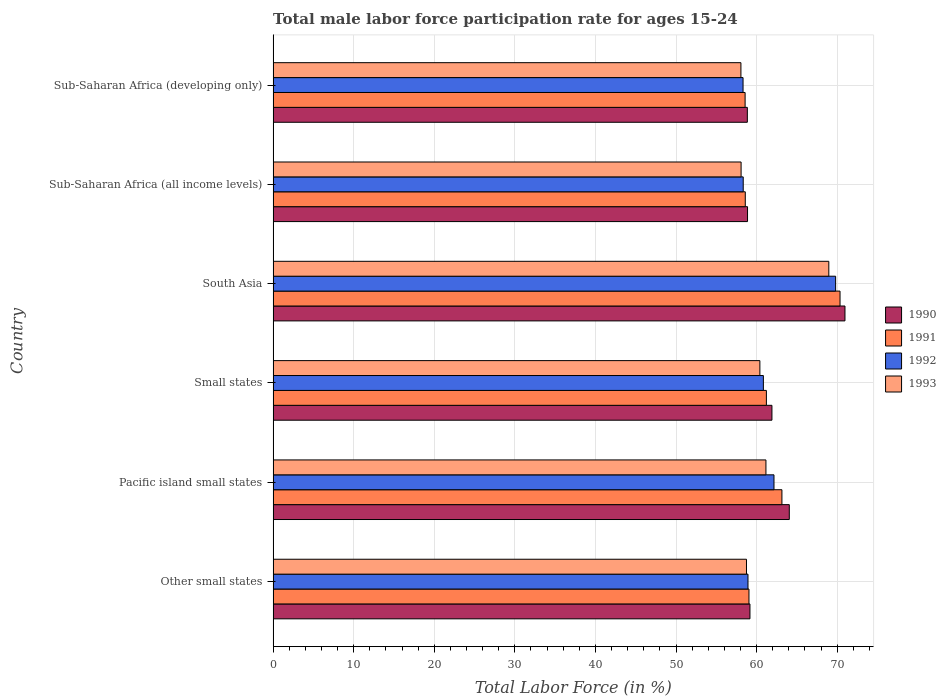How many different coloured bars are there?
Your answer should be very brief. 4. How many groups of bars are there?
Offer a terse response. 6. Are the number of bars on each tick of the Y-axis equal?
Your answer should be very brief. Yes. How many bars are there on the 4th tick from the bottom?
Your answer should be compact. 4. What is the label of the 5th group of bars from the top?
Your answer should be very brief. Pacific island small states. What is the male labor force participation rate in 1992 in South Asia?
Keep it short and to the point. 69.81. Across all countries, what is the maximum male labor force participation rate in 1992?
Keep it short and to the point. 69.81. Across all countries, what is the minimum male labor force participation rate in 1991?
Offer a terse response. 58.57. In which country was the male labor force participation rate in 1991 minimum?
Offer a very short reply. Sub-Saharan Africa (developing only). What is the total male labor force participation rate in 1991 in the graph?
Offer a terse response. 370.94. What is the difference between the male labor force participation rate in 1993 in Other small states and that in South Asia?
Give a very brief answer. -10.22. What is the difference between the male labor force participation rate in 1991 in Sub-Saharan Africa (all income levels) and the male labor force participation rate in 1992 in Other small states?
Provide a succinct answer. -0.34. What is the average male labor force participation rate in 1992 per country?
Your response must be concise. 61.4. What is the difference between the male labor force participation rate in 1993 and male labor force participation rate in 1992 in Pacific island small states?
Give a very brief answer. -1. In how many countries, is the male labor force participation rate in 1992 greater than 6 %?
Provide a succinct answer. 6. What is the ratio of the male labor force participation rate in 1993 in Other small states to that in South Asia?
Keep it short and to the point. 0.85. What is the difference between the highest and the second highest male labor force participation rate in 1991?
Make the answer very short. 7.21. What is the difference between the highest and the lowest male labor force participation rate in 1993?
Ensure brevity in your answer.  10.91. Is the sum of the male labor force participation rate in 1993 in South Asia and Sub-Saharan Africa (all income levels) greater than the maximum male labor force participation rate in 1992 across all countries?
Keep it short and to the point. Yes. Is it the case that in every country, the sum of the male labor force participation rate in 1992 and male labor force participation rate in 1993 is greater than the sum of male labor force participation rate in 1991 and male labor force participation rate in 1990?
Make the answer very short. No. What does the 2nd bar from the bottom in Sub-Saharan Africa (all income levels) represents?
Make the answer very short. 1991. Is it the case that in every country, the sum of the male labor force participation rate in 1990 and male labor force participation rate in 1993 is greater than the male labor force participation rate in 1992?
Keep it short and to the point. Yes. Are all the bars in the graph horizontal?
Ensure brevity in your answer.  Yes. How many countries are there in the graph?
Keep it short and to the point. 6. What is the difference between two consecutive major ticks on the X-axis?
Keep it short and to the point. 10. Are the values on the major ticks of X-axis written in scientific E-notation?
Give a very brief answer. No. Does the graph contain any zero values?
Provide a short and direct response. No. Where does the legend appear in the graph?
Provide a short and direct response. Center right. How are the legend labels stacked?
Offer a very short reply. Vertical. What is the title of the graph?
Provide a succinct answer. Total male labor force participation rate for ages 15-24. Does "2009" appear as one of the legend labels in the graph?
Your answer should be very brief. No. What is the label or title of the X-axis?
Make the answer very short. Total Labor Force (in %). What is the Total Labor Force (in %) of 1990 in Other small states?
Offer a very short reply. 59.18. What is the Total Labor Force (in %) in 1991 in Other small states?
Offer a very short reply. 59.05. What is the Total Labor Force (in %) of 1992 in Other small states?
Provide a succinct answer. 58.93. What is the Total Labor Force (in %) in 1993 in Other small states?
Offer a very short reply. 58.75. What is the Total Labor Force (in %) in 1990 in Pacific island small states?
Your answer should be compact. 64.06. What is the Total Labor Force (in %) in 1991 in Pacific island small states?
Make the answer very short. 63.15. What is the Total Labor Force (in %) of 1992 in Pacific island small states?
Your answer should be very brief. 62.16. What is the Total Labor Force (in %) of 1993 in Pacific island small states?
Your answer should be compact. 61.16. What is the Total Labor Force (in %) in 1990 in Small states?
Your response must be concise. 61.9. What is the Total Labor Force (in %) of 1991 in Small states?
Your answer should be very brief. 61.22. What is the Total Labor Force (in %) of 1992 in Small states?
Your answer should be compact. 60.84. What is the Total Labor Force (in %) in 1993 in Small states?
Provide a succinct answer. 60.41. What is the Total Labor Force (in %) in 1990 in South Asia?
Provide a succinct answer. 70.97. What is the Total Labor Force (in %) in 1991 in South Asia?
Offer a terse response. 70.36. What is the Total Labor Force (in %) of 1992 in South Asia?
Offer a very short reply. 69.81. What is the Total Labor Force (in %) in 1993 in South Asia?
Offer a terse response. 68.96. What is the Total Labor Force (in %) of 1990 in Sub-Saharan Africa (all income levels)?
Offer a terse response. 58.88. What is the Total Labor Force (in %) in 1991 in Sub-Saharan Africa (all income levels)?
Ensure brevity in your answer.  58.6. What is the Total Labor Force (in %) in 1992 in Sub-Saharan Africa (all income levels)?
Keep it short and to the point. 58.34. What is the Total Labor Force (in %) in 1993 in Sub-Saharan Africa (all income levels)?
Your answer should be compact. 58.08. What is the Total Labor Force (in %) in 1990 in Sub-Saharan Africa (developing only)?
Provide a short and direct response. 58.85. What is the Total Labor Force (in %) in 1991 in Sub-Saharan Africa (developing only)?
Provide a succinct answer. 58.57. What is the Total Labor Force (in %) of 1992 in Sub-Saharan Africa (developing only)?
Your response must be concise. 58.32. What is the Total Labor Force (in %) in 1993 in Sub-Saharan Africa (developing only)?
Ensure brevity in your answer.  58.06. Across all countries, what is the maximum Total Labor Force (in %) of 1990?
Keep it short and to the point. 70.97. Across all countries, what is the maximum Total Labor Force (in %) in 1991?
Keep it short and to the point. 70.36. Across all countries, what is the maximum Total Labor Force (in %) in 1992?
Your answer should be very brief. 69.81. Across all countries, what is the maximum Total Labor Force (in %) in 1993?
Offer a very short reply. 68.96. Across all countries, what is the minimum Total Labor Force (in %) in 1990?
Provide a succinct answer. 58.85. Across all countries, what is the minimum Total Labor Force (in %) in 1991?
Give a very brief answer. 58.57. Across all countries, what is the minimum Total Labor Force (in %) in 1992?
Your response must be concise. 58.32. Across all countries, what is the minimum Total Labor Force (in %) of 1993?
Offer a terse response. 58.06. What is the total Total Labor Force (in %) of 1990 in the graph?
Your answer should be very brief. 373.84. What is the total Total Labor Force (in %) of 1991 in the graph?
Ensure brevity in your answer.  370.94. What is the total Total Labor Force (in %) of 1992 in the graph?
Provide a short and direct response. 368.4. What is the total Total Labor Force (in %) in 1993 in the graph?
Offer a terse response. 365.41. What is the difference between the Total Labor Force (in %) of 1990 in Other small states and that in Pacific island small states?
Your answer should be compact. -4.88. What is the difference between the Total Labor Force (in %) of 1991 in Other small states and that in Pacific island small states?
Keep it short and to the point. -4.09. What is the difference between the Total Labor Force (in %) of 1992 in Other small states and that in Pacific island small states?
Offer a very short reply. -3.23. What is the difference between the Total Labor Force (in %) of 1993 in Other small states and that in Pacific island small states?
Your answer should be very brief. -2.42. What is the difference between the Total Labor Force (in %) of 1990 in Other small states and that in Small states?
Offer a very short reply. -2.73. What is the difference between the Total Labor Force (in %) in 1991 in Other small states and that in Small states?
Your answer should be very brief. -2.16. What is the difference between the Total Labor Force (in %) in 1992 in Other small states and that in Small states?
Provide a succinct answer. -1.91. What is the difference between the Total Labor Force (in %) of 1993 in Other small states and that in Small states?
Your answer should be compact. -1.66. What is the difference between the Total Labor Force (in %) in 1990 in Other small states and that in South Asia?
Make the answer very short. -11.79. What is the difference between the Total Labor Force (in %) in 1991 in Other small states and that in South Asia?
Your answer should be compact. -11.3. What is the difference between the Total Labor Force (in %) in 1992 in Other small states and that in South Asia?
Offer a very short reply. -10.88. What is the difference between the Total Labor Force (in %) of 1993 in Other small states and that in South Asia?
Offer a very short reply. -10.22. What is the difference between the Total Labor Force (in %) of 1990 in Other small states and that in Sub-Saharan Africa (all income levels)?
Offer a very short reply. 0.3. What is the difference between the Total Labor Force (in %) in 1991 in Other small states and that in Sub-Saharan Africa (all income levels)?
Provide a succinct answer. 0.46. What is the difference between the Total Labor Force (in %) of 1992 in Other small states and that in Sub-Saharan Africa (all income levels)?
Provide a short and direct response. 0.59. What is the difference between the Total Labor Force (in %) in 1993 in Other small states and that in Sub-Saharan Africa (all income levels)?
Give a very brief answer. 0.67. What is the difference between the Total Labor Force (in %) in 1990 in Other small states and that in Sub-Saharan Africa (developing only)?
Your answer should be compact. 0.32. What is the difference between the Total Labor Force (in %) in 1991 in Other small states and that in Sub-Saharan Africa (developing only)?
Your answer should be compact. 0.48. What is the difference between the Total Labor Force (in %) in 1992 in Other small states and that in Sub-Saharan Africa (developing only)?
Provide a succinct answer. 0.61. What is the difference between the Total Labor Force (in %) in 1993 in Other small states and that in Sub-Saharan Africa (developing only)?
Keep it short and to the point. 0.69. What is the difference between the Total Labor Force (in %) of 1990 in Pacific island small states and that in Small states?
Keep it short and to the point. 2.15. What is the difference between the Total Labor Force (in %) of 1991 in Pacific island small states and that in Small states?
Ensure brevity in your answer.  1.93. What is the difference between the Total Labor Force (in %) in 1992 in Pacific island small states and that in Small states?
Provide a succinct answer. 1.32. What is the difference between the Total Labor Force (in %) of 1993 in Pacific island small states and that in Small states?
Your answer should be very brief. 0.75. What is the difference between the Total Labor Force (in %) of 1990 in Pacific island small states and that in South Asia?
Your response must be concise. -6.91. What is the difference between the Total Labor Force (in %) in 1991 in Pacific island small states and that in South Asia?
Your answer should be compact. -7.21. What is the difference between the Total Labor Force (in %) of 1992 in Pacific island small states and that in South Asia?
Your response must be concise. -7.65. What is the difference between the Total Labor Force (in %) in 1993 in Pacific island small states and that in South Asia?
Your answer should be compact. -7.8. What is the difference between the Total Labor Force (in %) of 1990 in Pacific island small states and that in Sub-Saharan Africa (all income levels)?
Provide a short and direct response. 5.18. What is the difference between the Total Labor Force (in %) of 1991 in Pacific island small states and that in Sub-Saharan Africa (all income levels)?
Offer a terse response. 4.55. What is the difference between the Total Labor Force (in %) of 1992 in Pacific island small states and that in Sub-Saharan Africa (all income levels)?
Offer a very short reply. 3.82. What is the difference between the Total Labor Force (in %) of 1993 in Pacific island small states and that in Sub-Saharan Africa (all income levels)?
Your answer should be compact. 3.08. What is the difference between the Total Labor Force (in %) of 1990 in Pacific island small states and that in Sub-Saharan Africa (developing only)?
Your answer should be compact. 5.21. What is the difference between the Total Labor Force (in %) in 1991 in Pacific island small states and that in Sub-Saharan Africa (developing only)?
Your answer should be very brief. 4.57. What is the difference between the Total Labor Force (in %) of 1992 in Pacific island small states and that in Sub-Saharan Africa (developing only)?
Provide a succinct answer. 3.84. What is the difference between the Total Labor Force (in %) of 1993 in Pacific island small states and that in Sub-Saharan Africa (developing only)?
Ensure brevity in your answer.  3.1. What is the difference between the Total Labor Force (in %) of 1990 in Small states and that in South Asia?
Offer a terse response. -9.06. What is the difference between the Total Labor Force (in %) of 1991 in Small states and that in South Asia?
Give a very brief answer. -9.14. What is the difference between the Total Labor Force (in %) in 1992 in Small states and that in South Asia?
Ensure brevity in your answer.  -8.97. What is the difference between the Total Labor Force (in %) in 1993 in Small states and that in South Asia?
Make the answer very short. -8.55. What is the difference between the Total Labor Force (in %) of 1990 in Small states and that in Sub-Saharan Africa (all income levels)?
Your response must be concise. 3.03. What is the difference between the Total Labor Force (in %) of 1991 in Small states and that in Sub-Saharan Africa (all income levels)?
Ensure brevity in your answer.  2.62. What is the difference between the Total Labor Force (in %) of 1992 in Small states and that in Sub-Saharan Africa (all income levels)?
Make the answer very short. 2.5. What is the difference between the Total Labor Force (in %) of 1993 in Small states and that in Sub-Saharan Africa (all income levels)?
Provide a succinct answer. 2.33. What is the difference between the Total Labor Force (in %) of 1990 in Small states and that in Sub-Saharan Africa (developing only)?
Provide a succinct answer. 3.05. What is the difference between the Total Labor Force (in %) in 1991 in Small states and that in Sub-Saharan Africa (developing only)?
Your answer should be very brief. 2.64. What is the difference between the Total Labor Force (in %) of 1992 in Small states and that in Sub-Saharan Africa (developing only)?
Provide a short and direct response. 2.52. What is the difference between the Total Labor Force (in %) in 1993 in Small states and that in Sub-Saharan Africa (developing only)?
Keep it short and to the point. 2.35. What is the difference between the Total Labor Force (in %) of 1990 in South Asia and that in Sub-Saharan Africa (all income levels)?
Your answer should be very brief. 12.09. What is the difference between the Total Labor Force (in %) of 1991 in South Asia and that in Sub-Saharan Africa (all income levels)?
Your response must be concise. 11.76. What is the difference between the Total Labor Force (in %) in 1992 in South Asia and that in Sub-Saharan Africa (all income levels)?
Provide a short and direct response. 11.47. What is the difference between the Total Labor Force (in %) in 1993 in South Asia and that in Sub-Saharan Africa (all income levels)?
Offer a terse response. 10.89. What is the difference between the Total Labor Force (in %) of 1990 in South Asia and that in Sub-Saharan Africa (developing only)?
Make the answer very short. 12.11. What is the difference between the Total Labor Force (in %) of 1991 in South Asia and that in Sub-Saharan Africa (developing only)?
Offer a terse response. 11.78. What is the difference between the Total Labor Force (in %) of 1992 in South Asia and that in Sub-Saharan Africa (developing only)?
Give a very brief answer. 11.49. What is the difference between the Total Labor Force (in %) of 1993 in South Asia and that in Sub-Saharan Africa (developing only)?
Your response must be concise. 10.91. What is the difference between the Total Labor Force (in %) in 1990 in Sub-Saharan Africa (all income levels) and that in Sub-Saharan Africa (developing only)?
Your response must be concise. 0.02. What is the difference between the Total Labor Force (in %) in 1991 in Sub-Saharan Africa (all income levels) and that in Sub-Saharan Africa (developing only)?
Give a very brief answer. 0.02. What is the difference between the Total Labor Force (in %) in 1992 in Sub-Saharan Africa (all income levels) and that in Sub-Saharan Africa (developing only)?
Your answer should be very brief. 0.02. What is the difference between the Total Labor Force (in %) in 1993 in Sub-Saharan Africa (all income levels) and that in Sub-Saharan Africa (developing only)?
Offer a terse response. 0.02. What is the difference between the Total Labor Force (in %) in 1990 in Other small states and the Total Labor Force (in %) in 1991 in Pacific island small states?
Offer a terse response. -3.97. What is the difference between the Total Labor Force (in %) of 1990 in Other small states and the Total Labor Force (in %) of 1992 in Pacific island small states?
Your response must be concise. -2.98. What is the difference between the Total Labor Force (in %) of 1990 in Other small states and the Total Labor Force (in %) of 1993 in Pacific island small states?
Offer a very short reply. -1.98. What is the difference between the Total Labor Force (in %) of 1991 in Other small states and the Total Labor Force (in %) of 1992 in Pacific island small states?
Your response must be concise. -3.1. What is the difference between the Total Labor Force (in %) in 1991 in Other small states and the Total Labor Force (in %) in 1993 in Pacific island small states?
Your answer should be very brief. -2.11. What is the difference between the Total Labor Force (in %) of 1992 in Other small states and the Total Labor Force (in %) of 1993 in Pacific island small states?
Provide a succinct answer. -2.23. What is the difference between the Total Labor Force (in %) in 1990 in Other small states and the Total Labor Force (in %) in 1991 in Small states?
Give a very brief answer. -2.04. What is the difference between the Total Labor Force (in %) in 1990 in Other small states and the Total Labor Force (in %) in 1992 in Small states?
Your answer should be compact. -1.67. What is the difference between the Total Labor Force (in %) of 1990 in Other small states and the Total Labor Force (in %) of 1993 in Small states?
Give a very brief answer. -1.23. What is the difference between the Total Labor Force (in %) in 1991 in Other small states and the Total Labor Force (in %) in 1992 in Small states?
Your answer should be compact. -1.79. What is the difference between the Total Labor Force (in %) of 1991 in Other small states and the Total Labor Force (in %) of 1993 in Small states?
Your answer should be very brief. -1.35. What is the difference between the Total Labor Force (in %) in 1992 in Other small states and the Total Labor Force (in %) in 1993 in Small states?
Make the answer very short. -1.48. What is the difference between the Total Labor Force (in %) in 1990 in Other small states and the Total Labor Force (in %) in 1991 in South Asia?
Keep it short and to the point. -11.18. What is the difference between the Total Labor Force (in %) in 1990 in Other small states and the Total Labor Force (in %) in 1992 in South Asia?
Your answer should be compact. -10.63. What is the difference between the Total Labor Force (in %) of 1990 in Other small states and the Total Labor Force (in %) of 1993 in South Asia?
Your answer should be compact. -9.79. What is the difference between the Total Labor Force (in %) in 1991 in Other small states and the Total Labor Force (in %) in 1992 in South Asia?
Keep it short and to the point. -10.75. What is the difference between the Total Labor Force (in %) in 1991 in Other small states and the Total Labor Force (in %) in 1993 in South Asia?
Provide a succinct answer. -9.91. What is the difference between the Total Labor Force (in %) in 1992 in Other small states and the Total Labor Force (in %) in 1993 in South Asia?
Your response must be concise. -10.03. What is the difference between the Total Labor Force (in %) in 1990 in Other small states and the Total Labor Force (in %) in 1991 in Sub-Saharan Africa (all income levels)?
Provide a succinct answer. 0.58. What is the difference between the Total Labor Force (in %) of 1990 in Other small states and the Total Labor Force (in %) of 1992 in Sub-Saharan Africa (all income levels)?
Ensure brevity in your answer.  0.84. What is the difference between the Total Labor Force (in %) in 1990 in Other small states and the Total Labor Force (in %) in 1993 in Sub-Saharan Africa (all income levels)?
Your answer should be very brief. 1.1. What is the difference between the Total Labor Force (in %) in 1991 in Other small states and the Total Labor Force (in %) in 1992 in Sub-Saharan Africa (all income levels)?
Your answer should be very brief. 0.71. What is the difference between the Total Labor Force (in %) of 1991 in Other small states and the Total Labor Force (in %) of 1993 in Sub-Saharan Africa (all income levels)?
Your answer should be compact. 0.98. What is the difference between the Total Labor Force (in %) of 1992 in Other small states and the Total Labor Force (in %) of 1993 in Sub-Saharan Africa (all income levels)?
Make the answer very short. 0.86. What is the difference between the Total Labor Force (in %) of 1990 in Other small states and the Total Labor Force (in %) of 1991 in Sub-Saharan Africa (developing only)?
Provide a short and direct response. 0.6. What is the difference between the Total Labor Force (in %) of 1990 in Other small states and the Total Labor Force (in %) of 1992 in Sub-Saharan Africa (developing only)?
Your answer should be very brief. 0.86. What is the difference between the Total Labor Force (in %) in 1990 in Other small states and the Total Labor Force (in %) in 1993 in Sub-Saharan Africa (developing only)?
Provide a succinct answer. 1.12. What is the difference between the Total Labor Force (in %) in 1991 in Other small states and the Total Labor Force (in %) in 1992 in Sub-Saharan Africa (developing only)?
Provide a succinct answer. 0.73. What is the difference between the Total Labor Force (in %) in 1992 in Other small states and the Total Labor Force (in %) in 1993 in Sub-Saharan Africa (developing only)?
Your answer should be very brief. 0.88. What is the difference between the Total Labor Force (in %) in 1990 in Pacific island small states and the Total Labor Force (in %) in 1991 in Small states?
Make the answer very short. 2.84. What is the difference between the Total Labor Force (in %) of 1990 in Pacific island small states and the Total Labor Force (in %) of 1992 in Small states?
Provide a succinct answer. 3.22. What is the difference between the Total Labor Force (in %) of 1990 in Pacific island small states and the Total Labor Force (in %) of 1993 in Small states?
Offer a very short reply. 3.65. What is the difference between the Total Labor Force (in %) of 1991 in Pacific island small states and the Total Labor Force (in %) of 1992 in Small states?
Offer a very short reply. 2.3. What is the difference between the Total Labor Force (in %) in 1991 in Pacific island small states and the Total Labor Force (in %) in 1993 in Small states?
Give a very brief answer. 2.74. What is the difference between the Total Labor Force (in %) in 1992 in Pacific island small states and the Total Labor Force (in %) in 1993 in Small states?
Your response must be concise. 1.75. What is the difference between the Total Labor Force (in %) in 1990 in Pacific island small states and the Total Labor Force (in %) in 1991 in South Asia?
Your response must be concise. -6.3. What is the difference between the Total Labor Force (in %) of 1990 in Pacific island small states and the Total Labor Force (in %) of 1992 in South Asia?
Make the answer very short. -5.75. What is the difference between the Total Labor Force (in %) of 1990 in Pacific island small states and the Total Labor Force (in %) of 1993 in South Asia?
Provide a succinct answer. -4.9. What is the difference between the Total Labor Force (in %) in 1991 in Pacific island small states and the Total Labor Force (in %) in 1992 in South Asia?
Offer a very short reply. -6.66. What is the difference between the Total Labor Force (in %) of 1991 in Pacific island small states and the Total Labor Force (in %) of 1993 in South Asia?
Ensure brevity in your answer.  -5.82. What is the difference between the Total Labor Force (in %) in 1992 in Pacific island small states and the Total Labor Force (in %) in 1993 in South Asia?
Keep it short and to the point. -6.8. What is the difference between the Total Labor Force (in %) in 1990 in Pacific island small states and the Total Labor Force (in %) in 1991 in Sub-Saharan Africa (all income levels)?
Keep it short and to the point. 5.46. What is the difference between the Total Labor Force (in %) in 1990 in Pacific island small states and the Total Labor Force (in %) in 1992 in Sub-Saharan Africa (all income levels)?
Give a very brief answer. 5.72. What is the difference between the Total Labor Force (in %) of 1990 in Pacific island small states and the Total Labor Force (in %) of 1993 in Sub-Saharan Africa (all income levels)?
Provide a succinct answer. 5.98. What is the difference between the Total Labor Force (in %) in 1991 in Pacific island small states and the Total Labor Force (in %) in 1992 in Sub-Saharan Africa (all income levels)?
Your answer should be compact. 4.8. What is the difference between the Total Labor Force (in %) in 1991 in Pacific island small states and the Total Labor Force (in %) in 1993 in Sub-Saharan Africa (all income levels)?
Give a very brief answer. 5.07. What is the difference between the Total Labor Force (in %) of 1992 in Pacific island small states and the Total Labor Force (in %) of 1993 in Sub-Saharan Africa (all income levels)?
Your answer should be very brief. 4.08. What is the difference between the Total Labor Force (in %) in 1990 in Pacific island small states and the Total Labor Force (in %) in 1991 in Sub-Saharan Africa (developing only)?
Your response must be concise. 5.48. What is the difference between the Total Labor Force (in %) in 1990 in Pacific island small states and the Total Labor Force (in %) in 1992 in Sub-Saharan Africa (developing only)?
Your answer should be compact. 5.74. What is the difference between the Total Labor Force (in %) of 1990 in Pacific island small states and the Total Labor Force (in %) of 1993 in Sub-Saharan Africa (developing only)?
Offer a terse response. 6. What is the difference between the Total Labor Force (in %) in 1991 in Pacific island small states and the Total Labor Force (in %) in 1992 in Sub-Saharan Africa (developing only)?
Make the answer very short. 4.83. What is the difference between the Total Labor Force (in %) of 1991 in Pacific island small states and the Total Labor Force (in %) of 1993 in Sub-Saharan Africa (developing only)?
Your answer should be very brief. 5.09. What is the difference between the Total Labor Force (in %) of 1992 in Pacific island small states and the Total Labor Force (in %) of 1993 in Sub-Saharan Africa (developing only)?
Your answer should be compact. 4.1. What is the difference between the Total Labor Force (in %) in 1990 in Small states and the Total Labor Force (in %) in 1991 in South Asia?
Provide a short and direct response. -8.45. What is the difference between the Total Labor Force (in %) of 1990 in Small states and the Total Labor Force (in %) of 1992 in South Asia?
Offer a terse response. -7.9. What is the difference between the Total Labor Force (in %) in 1990 in Small states and the Total Labor Force (in %) in 1993 in South Asia?
Keep it short and to the point. -7.06. What is the difference between the Total Labor Force (in %) of 1991 in Small states and the Total Labor Force (in %) of 1992 in South Asia?
Your answer should be compact. -8.59. What is the difference between the Total Labor Force (in %) of 1991 in Small states and the Total Labor Force (in %) of 1993 in South Asia?
Provide a succinct answer. -7.75. What is the difference between the Total Labor Force (in %) of 1992 in Small states and the Total Labor Force (in %) of 1993 in South Asia?
Offer a terse response. -8.12. What is the difference between the Total Labor Force (in %) of 1990 in Small states and the Total Labor Force (in %) of 1991 in Sub-Saharan Africa (all income levels)?
Your response must be concise. 3.31. What is the difference between the Total Labor Force (in %) in 1990 in Small states and the Total Labor Force (in %) in 1992 in Sub-Saharan Africa (all income levels)?
Make the answer very short. 3.56. What is the difference between the Total Labor Force (in %) of 1990 in Small states and the Total Labor Force (in %) of 1993 in Sub-Saharan Africa (all income levels)?
Your answer should be compact. 3.83. What is the difference between the Total Labor Force (in %) in 1991 in Small states and the Total Labor Force (in %) in 1992 in Sub-Saharan Africa (all income levels)?
Offer a terse response. 2.88. What is the difference between the Total Labor Force (in %) of 1991 in Small states and the Total Labor Force (in %) of 1993 in Sub-Saharan Africa (all income levels)?
Make the answer very short. 3.14. What is the difference between the Total Labor Force (in %) of 1992 in Small states and the Total Labor Force (in %) of 1993 in Sub-Saharan Africa (all income levels)?
Provide a short and direct response. 2.77. What is the difference between the Total Labor Force (in %) of 1990 in Small states and the Total Labor Force (in %) of 1991 in Sub-Saharan Africa (developing only)?
Make the answer very short. 3.33. What is the difference between the Total Labor Force (in %) in 1990 in Small states and the Total Labor Force (in %) in 1992 in Sub-Saharan Africa (developing only)?
Keep it short and to the point. 3.58. What is the difference between the Total Labor Force (in %) in 1990 in Small states and the Total Labor Force (in %) in 1993 in Sub-Saharan Africa (developing only)?
Provide a short and direct response. 3.85. What is the difference between the Total Labor Force (in %) in 1991 in Small states and the Total Labor Force (in %) in 1992 in Sub-Saharan Africa (developing only)?
Your response must be concise. 2.9. What is the difference between the Total Labor Force (in %) of 1991 in Small states and the Total Labor Force (in %) of 1993 in Sub-Saharan Africa (developing only)?
Keep it short and to the point. 3.16. What is the difference between the Total Labor Force (in %) in 1992 in Small states and the Total Labor Force (in %) in 1993 in Sub-Saharan Africa (developing only)?
Ensure brevity in your answer.  2.79. What is the difference between the Total Labor Force (in %) in 1990 in South Asia and the Total Labor Force (in %) in 1991 in Sub-Saharan Africa (all income levels)?
Your response must be concise. 12.37. What is the difference between the Total Labor Force (in %) in 1990 in South Asia and the Total Labor Force (in %) in 1992 in Sub-Saharan Africa (all income levels)?
Your answer should be compact. 12.63. What is the difference between the Total Labor Force (in %) of 1990 in South Asia and the Total Labor Force (in %) of 1993 in Sub-Saharan Africa (all income levels)?
Make the answer very short. 12.89. What is the difference between the Total Labor Force (in %) in 1991 in South Asia and the Total Labor Force (in %) in 1992 in Sub-Saharan Africa (all income levels)?
Your answer should be compact. 12.02. What is the difference between the Total Labor Force (in %) in 1991 in South Asia and the Total Labor Force (in %) in 1993 in Sub-Saharan Africa (all income levels)?
Your response must be concise. 12.28. What is the difference between the Total Labor Force (in %) of 1992 in South Asia and the Total Labor Force (in %) of 1993 in Sub-Saharan Africa (all income levels)?
Your answer should be very brief. 11.73. What is the difference between the Total Labor Force (in %) in 1990 in South Asia and the Total Labor Force (in %) in 1991 in Sub-Saharan Africa (developing only)?
Ensure brevity in your answer.  12.39. What is the difference between the Total Labor Force (in %) of 1990 in South Asia and the Total Labor Force (in %) of 1992 in Sub-Saharan Africa (developing only)?
Give a very brief answer. 12.65. What is the difference between the Total Labor Force (in %) of 1990 in South Asia and the Total Labor Force (in %) of 1993 in Sub-Saharan Africa (developing only)?
Your response must be concise. 12.91. What is the difference between the Total Labor Force (in %) in 1991 in South Asia and the Total Labor Force (in %) in 1992 in Sub-Saharan Africa (developing only)?
Provide a short and direct response. 12.04. What is the difference between the Total Labor Force (in %) in 1991 in South Asia and the Total Labor Force (in %) in 1993 in Sub-Saharan Africa (developing only)?
Give a very brief answer. 12.3. What is the difference between the Total Labor Force (in %) of 1992 in South Asia and the Total Labor Force (in %) of 1993 in Sub-Saharan Africa (developing only)?
Ensure brevity in your answer.  11.75. What is the difference between the Total Labor Force (in %) of 1990 in Sub-Saharan Africa (all income levels) and the Total Labor Force (in %) of 1991 in Sub-Saharan Africa (developing only)?
Your response must be concise. 0.3. What is the difference between the Total Labor Force (in %) in 1990 in Sub-Saharan Africa (all income levels) and the Total Labor Force (in %) in 1992 in Sub-Saharan Africa (developing only)?
Provide a short and direct response. 0.56. What is the difference between the Total Labor Force (in %) in 1990 in Sub-Saharan Africa (all income levels) and the Total Labor Force (in %) in 1993 in Sub-Saharan Africa (developing only)?
Provide a short and direct response. 0.82. What is the difference between the Total Labor Force (in %) of 1991 in Sub-Saharan Africa (all income levels) and the Total Labor Force (in %) of 1992 in Sub-Saharan Africa (developing only)?
Your answer should be compact. 0.28. What is the difference between the Total Labor Force (in %) in 1991 in Sub-Saharan Africa (all income levels) and the Total Labor Force (in %) in 1993 in Sub-Saharan Africa (developing only)?
Your answer should be compact. 0.54. What is the difference between the Total Labor Force (in %) of 1992 in Sub-Saharan Africa (all income levels) and the Total Labor Force (in %) of 1993 in Sub-Saharan Africa (developing only)?
Ensure brevity in your answer.  0.28. What is the average Total Labor Force (in %) in 1990 per country?
Make the answer very short. 62.31. What is the average Total Labor Force (in %) in 1991 per country?
Your answer should be compact. 61.82. What is the average Total Labor Force (in %) in 1992 per country?
Provide a short and direct response. 61.4. What is the average Total Labor Force (in %) in 1993 per country?
Ensure brevity in your answer.  60.9. What is the difference between the Total Labor Force (in %) in 1990 and Total Labor Force (in %) in 1991 in Other small states?
Offer a very short reply. 0.12. What is the difference between the Total Labor Force (in %) in 1990 and Total Labor Force (in %) in 1992 in Other small states?
Provide a short and direct response. 0.24. What is the difference between the Total Labor Force (in %) of 1990 and Total Labor Force (in %) of 1993 in Other small states?
Provide a succinct answer. 0.43. What is the difference between the Total Labor Force (in %) in 1991 and Total Labor Force (in %) in 1992 in Other small states?
Your response must be concise. 0.12. What is the difference between the Total Labor Force (in %) in 1991 and Total Labor Force (in %) in 1993 in Other small states?
Provide a succinct answer. 0.31. What is the difference between the Total Labor Force (in %) in 1992 and Total Labor Force (in %) in 1993 in Other small states?
Your response must be concise. 0.19. What is the difference between the Total Labor Force (in %) of 1990 and Total Labor Force (in %) of 1991 in Pacific island small states?
Offer a very short reply. 0.91. What is the difference between the Total Labor Force (in %) of 1990 and Total Labor Force (in %) of 1992 in Pacific island small states?
Your answer should be very brief. 1.9. What is the difference between the Total Labor Force (in %) in 1990 and Total Labor Force (in %) in 1993 in Pacific island small states?
Give a very brief answer. 2.9. What is the difference between the Total Labor Force (in %) in 1991 and Total Labor Force (in %) in 1992 in Pacific island small states?
Ensure brevity in your answer.  0.99. What is the difference between the Total Labor Force (in %) in 1991 and Total Labor Force (in %) in 1993 in Pacific island small states?
Offer a very short reply. 1.98. What is the difference between the Total Labor Force (in %) in 1992 and Total Labor Force (in %) in 1993 in Pacific island small states?
Offer a very short reply. 1. What is the difference between the Total Labor Force (in %) in 1990 and Total Labor Force (in %) in 1991 in Small states?
Offer a terse response. 0.69. What is the difference between the Total Labor Force (in %) in 1990 and Total Labor Force (in %) in 1992 in Small states?
Your response must be concise. 1.06. What is the difference between the Total Labor Force (in %) in 1990 and Total Labor Force (in %) in 1993 in Small states?
Your answer should be compact. 1.5. What is the difference between the Total Labor Force (in %) of 1991 and Total Labor Force (in %) of 1992 in Small states?
Provide a succinct answer. 0.37. What is the difference between the Total Labor Force (in %) of 1991 and Total Labor Force (in %) of 1993 in Small states?
Offer a very short reply. 0.81. What is the difference between the Total Labor Force (in %) in 1992 and Total Labor Force (in %) in 1993 in Small states?
Your response must be concise. 0.43. What is the difference between the Total Labor Force (in %) in 1990 and Total Labor Force (in %) in 1991 in South Asia?
Your answer should be compact. 0.61. What is the difference between the Total Labor Force (in %) of 1990 and Total Labor Force (in %) of 1992 in South Asia?
Make the answer very short. 1.16. What is the difference between the Total Labor Force (in %) of 1990 and Total Labor Force (in %) of 1993 in South Asia?
Ensure brevity in your answer.  2. What is the difference between the Total Labor Force (in %) of 1991 and Total Labor Force (in %) of 1992 in South Asia?
Provide a short and direct response. 0.55. What is the difference between the Total Labor Force (in %) in 1991 and Total Labor Force (in %) in 1993 in South Asia?
Your answer should be compact. 1.39. What is the difference between the Total Labor Force (in %) in 1992 and Total Labor Force (in %) in 1993 in South Asia?
Your response must be concise. 0.85. What is the difference between the Total Labor Force (in %) of 1990 and Total Labor Force (in %) of 1991 in Sub-Saharan Africa (all income levels)?
Provide a succinct answer. 0.28. What is the difference between the Total Labor Force (in %) of 1990 and Total Labor Force (in %) of 1992 in Sub-Saharan Africa (all income levels)?
Provide a short and direct response. 0.53. What is the difference between the Total Labor Force (in %) of 1990 and Total Labor Force (in %) of 1993 in Sub-Saharan Africa (all income levels)?
Your answer should be very brief. 0.8. What is the difference between the Total Labor Force (in %) in 1991 and Total Labor Force (in %) in 1992 in Sub-Saharan Africa (all income levels)?
Offer a very short reply. 0.26. What is the difference between the Total Labor Force (in %) of 1991 and Total Labor Force (in %) of 1993 in Sub-Saharan Africa (all income levels)?
Provide a short and direct response. 0.52. What is the difference between the Total Labor Force (in %) in 1992 and Total Labor Force (in %) in 1993 in Sub-Saharan Africa (all income levels)?
Your answer should be very brief. 0.26. What is the difference between the Total Labor Force (in %) in 1990 and Total Labor Force (in %) in 1991 in Sub-Saharan Africa (developing only)?
Provide a succinct answer. 0.28. What is the difference between the Total Labor Force (in %) in 1990 and Total Labor Force (in %) in 1992 in Sub-Saharan Africa (developing only)?
Your answer should be compact. 0.53. What is the difference between the Total Labor Force (in %) in 1990 and Total Labor Force (in %) in 1993 in Sub-Saharan Africa (developing only)?
Offer a very short reply. 0.8. What is the difference between the Total Labor Force (in %) of 1991 and Total Labor Force (in %) of 1992 in Sub-Saharan Africa (developing only)?
Provide a succinct answer. 0.25. What is the difference between the Total Labor Force (in %) in 1991 and Total Labor Force (in %) in 1993 in Sub-Saharan Africa (developing only)?
Make the answer very short. 0.52. What is the difference between the Total Labor Force (in %) in 1992 and Total Labor Force (in %) in 1993 in Sub-Saharan Africa (developing only)?
Provide a succinct answer. 0.26. What is the ratio of the Total Labor Force (in %) in 1990 in Other small states to that in Pacific island small states?
Provide a succinct answer. 0.92. What is the ratio of the Total Labor Force (in %) of 1991 in Other small states to that in Pacific island small states?
Keep it short and to the point. 0.94. What is the ratio of the Total Labor Force (in %) in 1992 in Other small states to that in Pacific island small states?
Ensure brevity in your answer.  0.95. What is the ratio of the Total Labor Force (in %) in 1993 in Other small states to that in Pacific island small states?
Provide a short and direct response. 0.96. What is the ratio of the Total Labor Force (in %) in 1990 in Other small states to that in Small states?
Keep it short and to the point. 0.96. What is the ratio of the Total Labor Force (in %) in 1991 in Other small states to that in Small states?
Make the answer very short. 0.96. What is the ratio of the Total Labor Force (in %) of 1992 in Other small states to that in Small states?
Your response must be concise. 0.97. What is the ratio of the Total Labor Force (in %) of 1993 in Other small states to that in Small states?
Ensure brevity in your answer.  0.97. What is the ratio of the Total Labor Force (in %) of 1990 in Other small states to that in South Asia?
Give a very brief answer. 0.83. What is the ratio of the Total Labor Force (in %) of 1991 in Other small states to that in South Asia?
Provide a short and direct response. 0.84. What is the ratio of the Total Labor Force (in %) of 1992 in Other small states to that in South Asia?
Provide a short and direct response. 0.84. What is the ratio of the Total Labor Force (in %) of 1993 in Other small states to that in South Asia?
Your response must be concise. 0.85. What is the ratio of the Total Labor Force (in %) in 1990 in Other small states to that in Sub-Saharan Africa (all income levels)?
Your answer should be very brief. 1.01. What is the ratio of the Total Labor Force (in %) in 1992 in Other small states to that in Sub-Saharan Africa (all income levels)?
Provide a short and direct response. 1.01. What is the ratio of the Total Labor Force (in %) of 1993 in Other small states to that in Sub-Saharan Africa (all income levels)?
Make the answer very short. 1.01. What is the ratio of the Total Labor Force (in %) in 1990 in Other small states to that in Sub-Saharan Africa (developing only)?
Offer a very short reply. 1.01. What is the ratio of the Total Labor Force (in %) of 1991 in Other small states to that in Sub-Saharan Africa (developing only)?
Provide a short and direct response. 1.01. What is the ratio of the Total Labor Force (in %) in 1992 in Other small states to that in Sub-Saharan Africa (developing only)?
Keep it short and to the point. 1.01. What is the ratio of the Total Labor Force (in %) in 1993 in Other small states to that in Sub-Saharan Africa (developing only)?
Your answer should be compact. 1.01. What is the ratio of the Total Labor Force (in %) of 1990 in Pacific island small states to that in Small states?
Keep it short and to the point. 1.03. What is the ratio of the Total Labor Force (in %) of 1991 in Pacific island small states to that in Small states?
Provide a short and direct response. 1.03. What is the ratio of the Total Labor Force (in %) of 1992 in Pacific island small states to that in Small states?
Offer a very short reply. 1.02. What is the ratio of the Total Labor Force (in %) in 1993 in Pacific island small states to that in Small states?
Provide a short and direct response. 1.01. What is the ratio of the Total Labor Force (in %) of 1990 in Pacific island small states to that in South Asia?
Your answer should be very brief. 0.9. What is the ratio of the Total Labor Force (in %) of 1991 in Pacific island small states to that in South Asia?
Your answer should be very brief. 0.9. What is the ratio of the Total Labor Force (in %) of 1992 in Pacific island small states to that in South Asia?
Provide a short and direct response. 0.89. What is the ratio of the Total Labor Force (in %) in 1993 in Pacific island small states to that in South Asia?
Your answer should be compact. 0.89. What is the ratio of the Total Labor Force (in %) in 1990 in Pacific island small states to that in Sub-Saharan Africa (all income levels)?
Your response must be concise. 1.09. What is the ratio of the Total Labor Force (in %) in 1991 in Pacific island small states to that in Sub-Saharan Africa (all income levels)?
Your response must be concise. 1.08. What is the ratio of the Total Labor Force (in %) of 1992 in Pacific island small states to that in Sub-Saharan Africa (all income levels)?
Your answer should be very brief. 1.07. What is the ratio of the Total Labor Force (in %) in 1993 in Pacific island small states to that in Sub-Saharan Africa (all income levels)?
Make the answer very short. 1.05. What is the ratio of the Total Labor Force (in %) in 1990 in Pacific island small states to that in Sub-Saharan Africa (developing only)?
Your answer should be compact. 1.09. What is the ratio of the Total Labor Force (in %) of 1991 in Pacific island small states to that in Sub-Saharan Africa (developing only)?
Offer a very short reply. 1.08. What is the ratio of the Total Labor Force (in %) of 1992 in Pacific island small states to that in Sub-Saharan Africa (developing only)?
Give a very brief answer. 1.07. What is the ratio of the Total Labor Force (in %) of 1993 in Pacific island small states to that in Sub-Saharan Africa (developing only)?
Keep it short and to the point. 1.05. What is the ratio of the Total Labor Force (in %) of 1990 in Small states to that in South Asia?
Make the answer very short. 0.87. What is the ratio of the Total Labor Force (in %) in 1991 in Small states to that in South Asia?
Give a very brief answer. 0.87. What is the ratio of the Total Labor Force (in %) of 1992 in Small states to that in South Asia?
Offer a very short reply. 0.87. What is the ratio of the Total Labor Force (in %) of 1993 in Small states to that in South Asia?
Keep it short and to the point. 0.88. What is the ratio of the Total Labor Force (in %) in 1990 in Small states to that in Sub-Saharan Africa (all income levels)?
Offer a terse response. 1.05. What is the ratio of the Total Labor Force (in %) in 1991 in Small states to that in Sub-Saharan Africa (all income levels)?
Provide a succinct answer. 1.04. What is the ratio of the Total Labor Force (in %) in 1992 in Small states to that in Sub-Saharan Africa (all income levels)?
Offer a terse response. 1.04. What is the ratio of the Total Labor Force (in %) of 1993 in Small states to that in Sub-Saharan Africa (all income levels)?
Your answer should be very brief. 1.04. What is the ratio of the Total Labor Force (in %) in 1990 in Small states to that in Sub-Saharan Africa (developing only)?
Provide a succinct answer. 1.05. What is the ratio of the Total Labor Force (in %) in 1991 in Small states to that in Sub-Saharan Africa (developing only)?
Give a very brief answer. 1.05. What is the ratio of the Total Labor Force (in %) of 1992 in Small states to that in Sub-Saharan Africa (developing only)?
Provide a succinct answer. 1.04. What is the ratio of the Total Labor Force (in %) in 1993 in Small states to that in Sub-Saharan Africa (developing only)?
Offer a very short reply. 1.04. What is the ratio of the Total Labor Force (in %) of 1990 in South Asia to that in Sub-Saharan Africa (all income levels)?
Provide a short and direct response. 1.21. What is the ratio of the Total Labor Force (in %) of 1991 in South Asia to that in Sub-Saharan Africa (all income levels)?
Your response must be concise. 1.2. What is the ratio of the Total Labor Force (in %) in 1992 in South Asia to that in Sub-Saharan Africa (all income levels)?
Offer a very short reply. 1.2. What is the ratio of the Total Labor Force (in %) of 1993 in South Asia to that in Sub-Saharan Africa (all income levels)?
Provide a succinct answer. 1.19. What is the ratio of the Total Labor Force (in %) in 1990 in South Asia to that in Sub-Saharan Africa (developing only)?
Provide a short and direct response. 1.21. What is the ratio of the Total Labor Force (in %) of 1991 in South Asia to that in Sub-Saharan Africa (developing only)?
Offer a very short reply. 1.2. What is the ratio of the Total Labor Force (in %) in 1992 in South Asia to that in Sub-Saharan Africa (developing only)?
Your answer should be very brief. 1.2. What is the ratio of the Total Labor Force (in %) in 1993 in South Asia to that in Sub-Saharan Africa (developing only)?
Your response must be concise. 1.19. What is the difference between the highest and the second highest Total Labor Force (in %) of 1990?
Your response must be concise. 6.91. What is the difference between the highest and the second highest Total Labor Force (in %) in 1991?
Offer a very short reply. 7.21. What is the difference between the highest and the second highest Total Labor Force (in %) in 1992?
Keep it short and to the point. 7.65. What is the difference between the highest and the second highest Total Labor Force (in %) in 1993?
Provide a succinct answer. 7.8. What is the difference between the highest and the lowest Total Labor Force (in %) of 1990?
Provide a short and direct response. 12.11. What is the difference between the highest and the lowest Total Labor Force (in %) in 1991?
Your answer should be very brief. 11.78. What is the difference between the highest and the lowest Total Labor Force (in %) in 1992?
Offer a terse response. 11.49. What is the difference between the highest and the lowest Total Labor Force (in %) in 1993?
Offer a terse response. 10.91. 